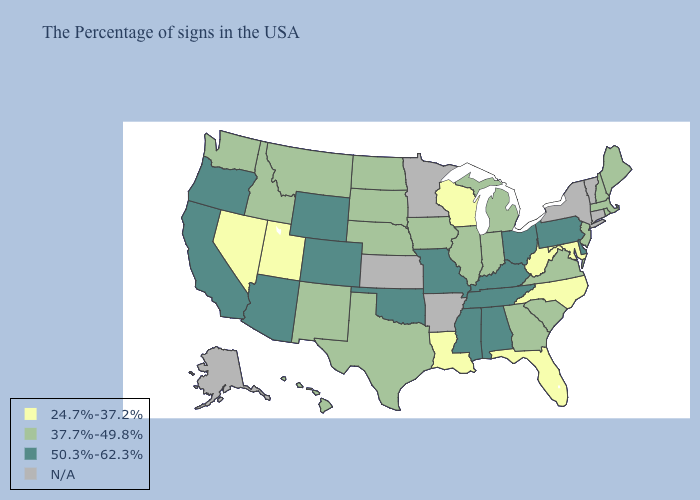What is the lowest value in the USA?
Write a very short answer. 24.7%-37.2%. Which states have the lowest value in the USA?
Answer briefly. Maryland, North Carolina, West Virginia, Florida, Wisconsin, Louisiana, Utah, Nevada. Does Virginia have the highest value in the USA?
Give a very brief answer. No. Name the states that have a value in the range 50.3%-62.3%?
Write a very short answer. Delaware, Pennsylvania, Ohio, Kentucky, Alabama, Tennessee, Mississippi, Missouri, Oklahoma, Wyoming, Colorado, Arizona, California, Oregon. Which states hav the highest value in the Northeast?
Quick response, please. Pennsylvania. What is the highest value in the USA?
Give a very brief answer. 50.3%-62.3%. What is the highest value in the MidWest ?
Quick response, please. 50.3%-62.3%. Which states have the lowest value in the Northeast?
Short answer required. Maine, Massachusetts, Rhode Island, New Hampshire, New Jersey. Does Washington have the lowest value in the USA?
Write a very short answer. No. What is the highest value in states that border Minnesota?
Be succinct. 37.7%-49.8%. Name the states that have a value in the range 24.7%-37.2%?
Answer briefly. Maryland, North Carolina, West Virginia, Florida, Wisconsin, Louisiana, Utah, Nevada. Which states have the lowest value in the USA?
Be succinct. Maryland, North Carolina, West Virginia, Florida, Wisconsin, Louisiana, Utah, Nevada. Name the states that have a value in the range 37.7%-49.8%?
Give a very brief answer. Maine, Massachusetts, Rhode Island, New Hampshire, New Jersey, Virginia, South Carolina, Georgia, Michigan, Indiana, Illinois, Iowa, Nebraska, Texas, South Dakota, North Dakota, New Mexico, Montana, Idaho, Washington, Hawaii. What is the value of Maine?
Answer briefly. 37.7%-49.8%. 